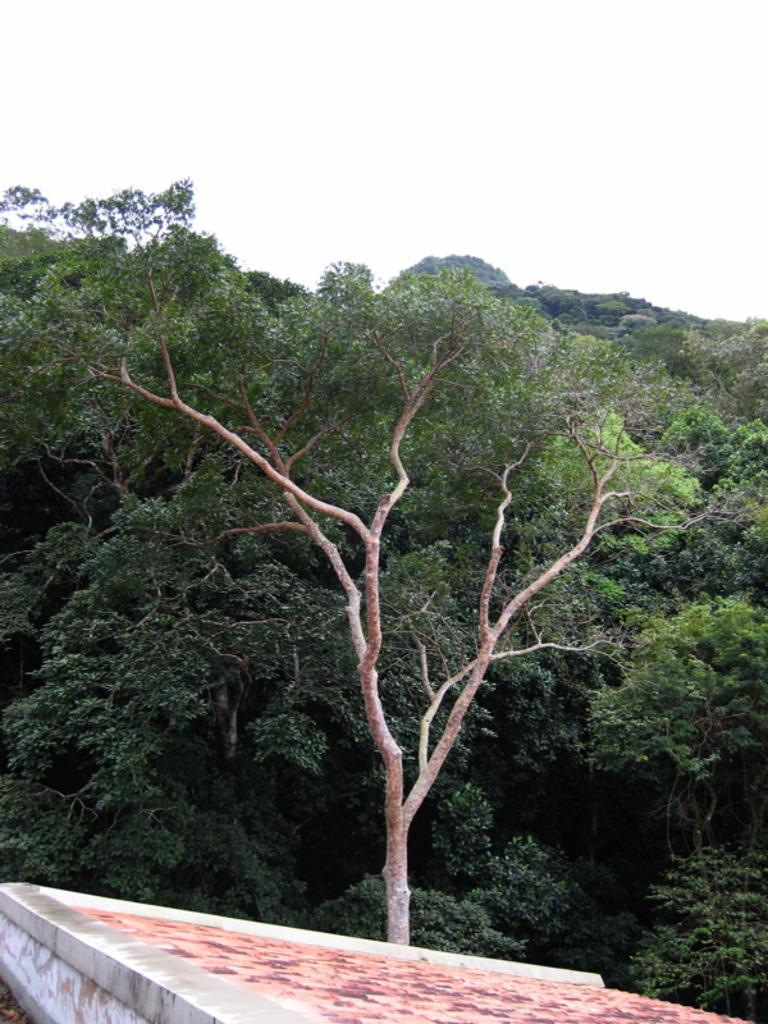What type of terrain is visible at the bottom of the image? There is a slope at the bottom of the image. What structure is present at the bottom of the image? There is a wall at the bottom of the image. What type of vegetation can be seen in the background of the image? There are trees in the background of the image. What is visible at the top of the image? The sky is visible at the top of the image. What color is the crayon used to draw the trees in the image? There is no crayon present in the image; the trees are depicted using photographic or artistic techniques. Can you tell me how many ice cubes are in the sky in the image? There are no ice cubes present in the sky in the image; it is a clear sky. 